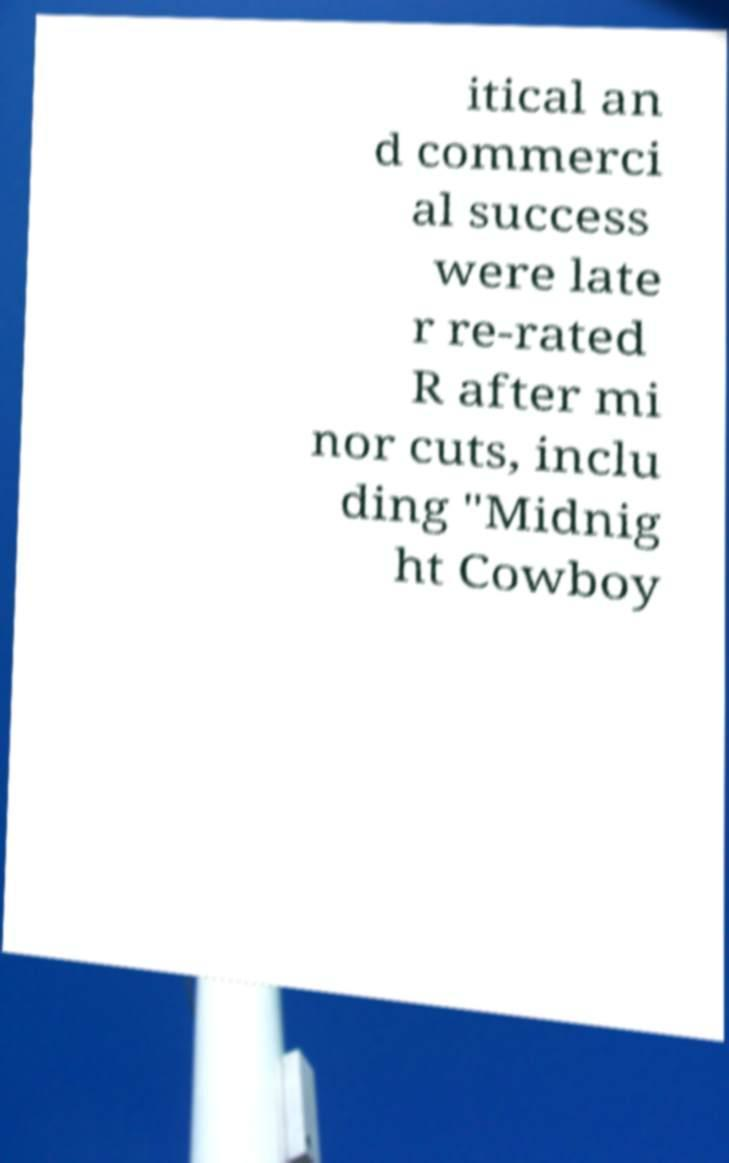Could you assist in decoding the text presented in this image and type it out clearly? itical an d commerci al success were late r re-rated R after mi nor cuts, inclu ding "Midnig ht Cowboy 